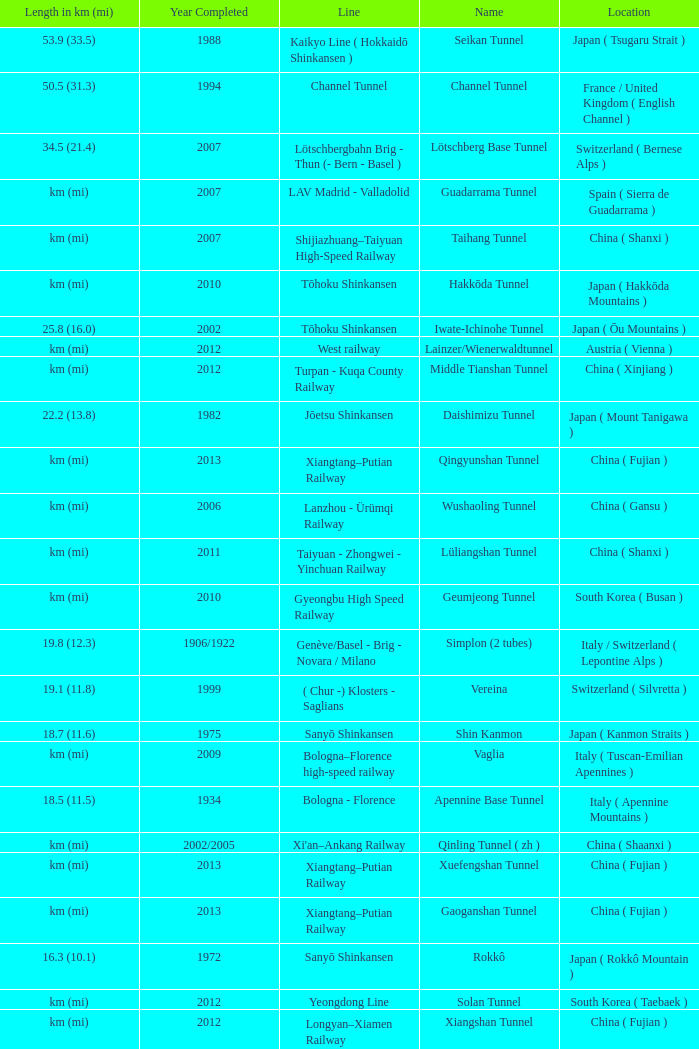What year was the Line of Gardermobanen completed? 1999.0. 